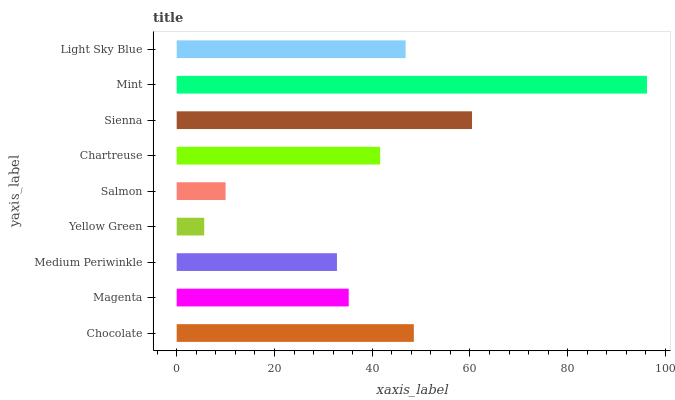Is Yellow Green the minimum?
Answer yes or no. Yes. Is Mint the maximum?
Answer yes or no. Yes. Is Magenta the minimum?
Answer yes or no. No. Is Magenta the maximum?
Answer yes or no. No. Is Chocolate greater than Magenta?
Answer yes or no. Yes. Is Magenta less than Chocolate?
Answer yes or no. Yes. Is Magenta greater than Chocolate?
Answer yes or no. No. Is Chocolate less than Magenta?
Answer yes or no. No. Is Chartreuse the high median?
Answer yes or no. Yes. Is Chartreuse the low median?
Answer yes or no. Yes. Is Chocolate the high median?
Answer yes or no. No. Is Salmon the low median?
Answer yes or no. No. 